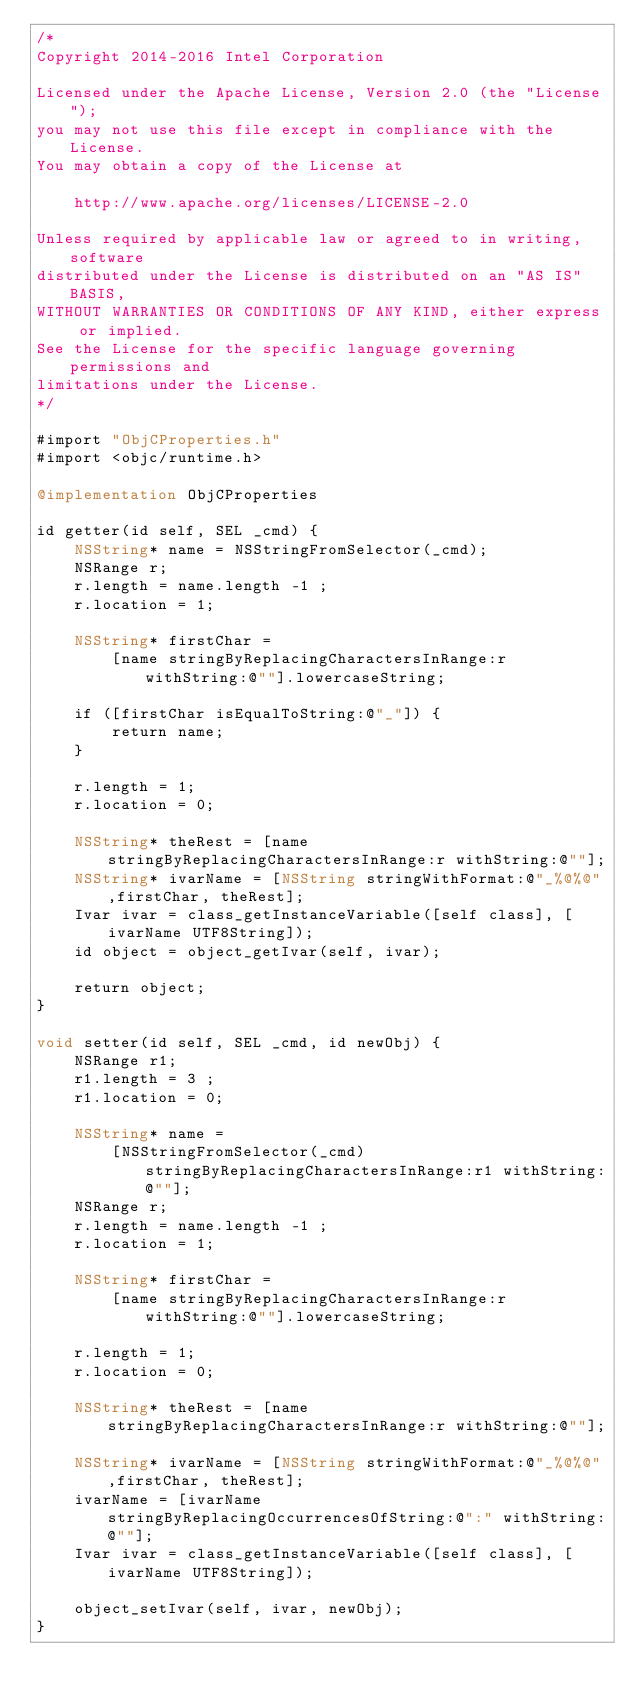<code> <loc_0><loc_0><loc_500><loc_500><_ObjectiveC_>/*
Copyright 2014-2016 Intel Corporation

Licensed under the Apache License, Version 2.0 (the "License");
you may not use this file except in compliance with the License.
You may obtain a copy of the License at

    http://www.apache.org/licenses/LICENSE-2.0

Unless required by applicable law or agreed to in writing, software
distributed under the License is distributed on an "AS IS" BASIS,
WITHOUT WARRANTIES OR CONDITIONS OF ANY KIND, either express or implied.
See the License for the specific language governing permissions and
limitations under the License.
*/

#import "ObjCProperties.h"
#import <objc/runtime.h>

@implementation ObjCProperties

id getter(id self, SEL _cmd) {
    NSString* name = NSStringFromSelector(_cmd);
    NSRange r;
    r.length = name.length -1 ;
    r.location = 1;
    
    NSString* firstChar =
        [name stringByReplacingCharactersInRange:r withString:@""].lowercaseString;
    
    if ([firstChar isEqualToString:@"_"]) {
        return name;
    }
    
    r.length = 1;
    r.location = 0;
    
    NSString* theRest = [name stringByReplacingCharactersInRange:r withString:@""];
    NSString* ivarName = [NSString stringWithFormat:@"_%@%@",firstChar, theRest];
    Ivar ivar = class_getInstanceVariable([self class], [ivarName UTF8String]);
    id object = object_getIvar(self, ivar);
    
    return object;
}

void setter(id self, SEL _cmd, id newObj) {
    NSRange r1;
    r1.length = 3 ;
    r1.location = 0;
    
    NSString* name =
        [NSStringFromSelector(_cmd) stringByReplacingCharactersInRange:r1 withString:@""];
    NSRange r;
    r.length = name.length -1 ;
    r.location = 1;
    
    NSString* firstChar =
        [name stringByReplacingCharactersInRange:r withString:@""].lowercaseString;
    
    r.length = 1;
    r.location = 0;
    
    NSString* theRest = [name stringByReplacingCharactersInRange:r withString:@""];
    
    NSString* ivarName = [NSString stringWithFormat:@"_%@%@",firstChar, theRest];
    ivarName = [ivarName stringByReplacingOccurrencesOfString:@":" withString:@""];
    Ivar ivar = class_getInstanceVariable([self class], [ivarName UTF8String]);
    
    object_setIvar(self, ivar, newObj);
}
</code> 